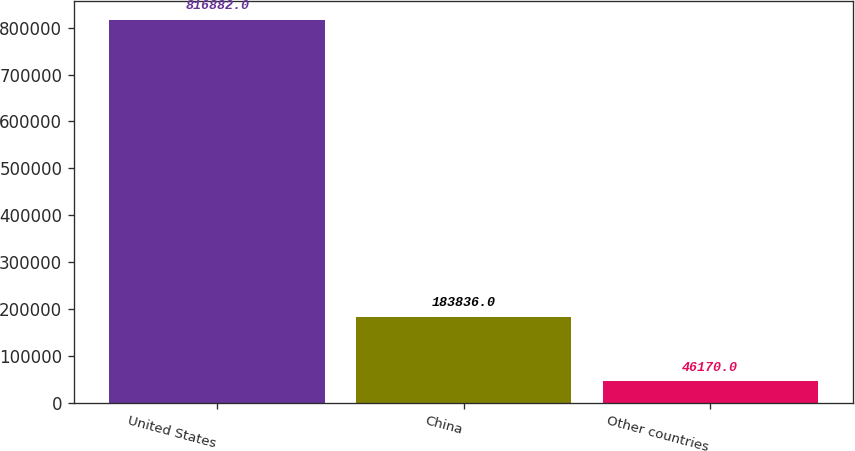<chart> <loc_0><loc_0><loc_500><loc_500><bar_chart><fcel>United States<fcel>China<fcel>Other countries<nl><fcel>816882<fcel>183836<fcel>46170<nl></chart> 